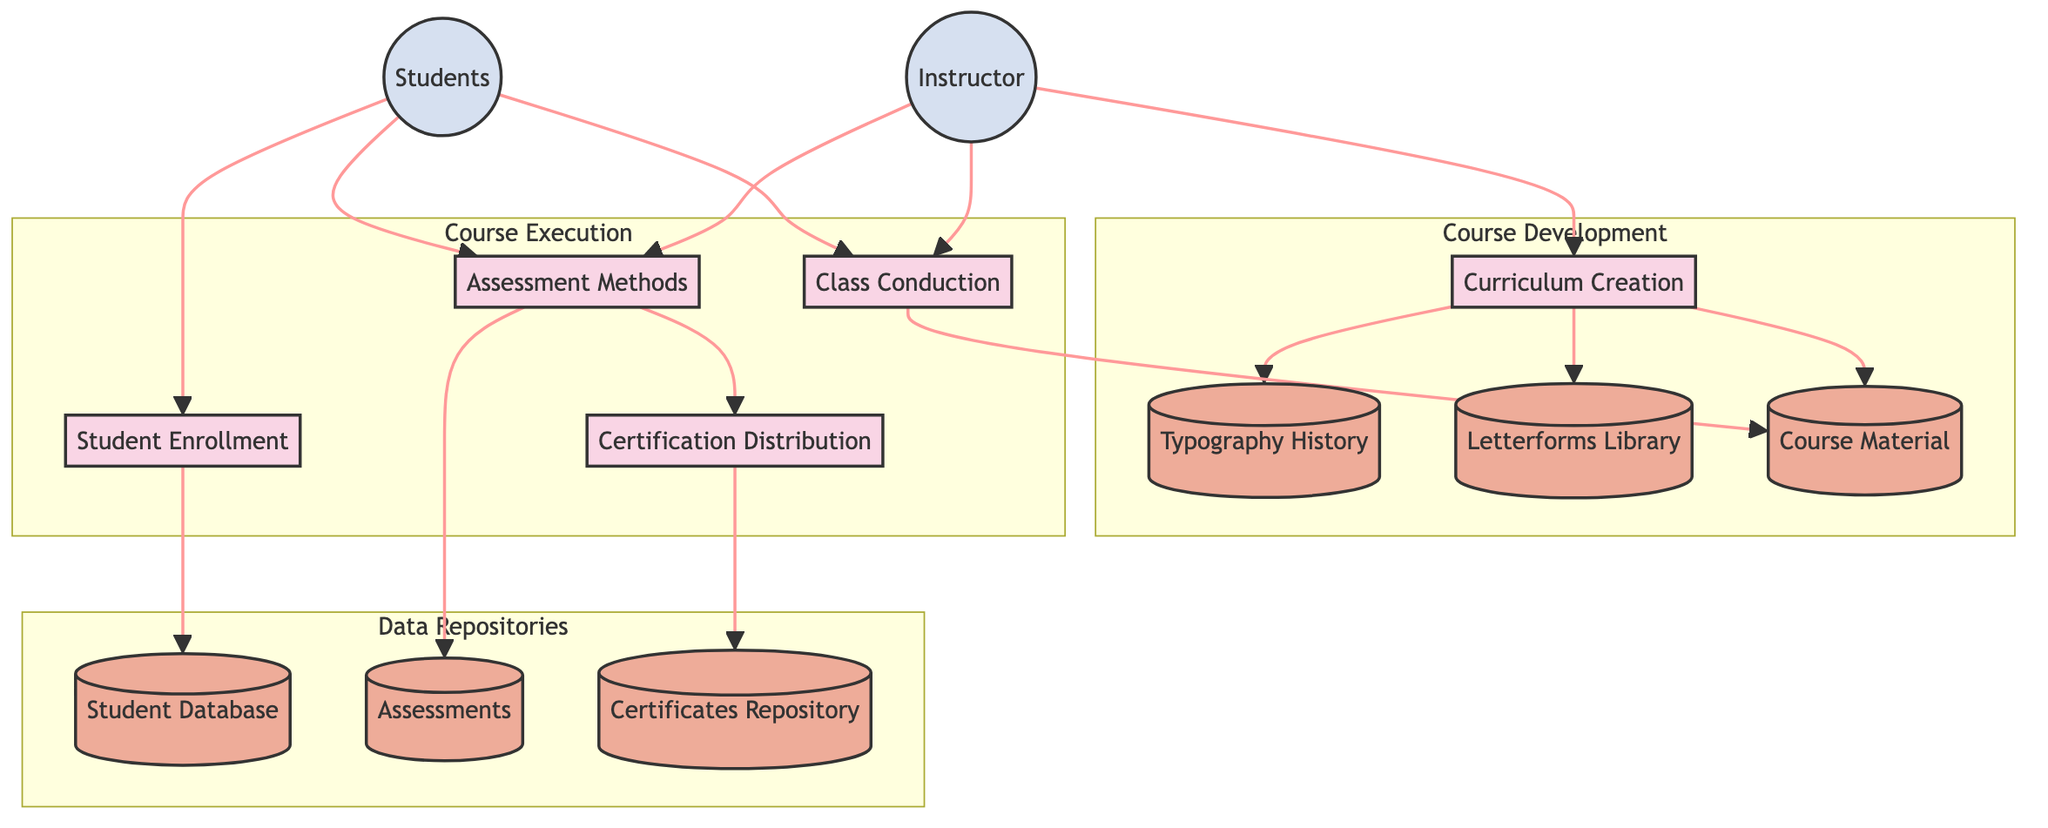What is the first process in the diagram? The first process that appears in the Data Flow Diagram is "Curriculum Creation." It is the starting point of the course development sequence.
Answer: Curriculum Creation How many data stores are present in the diagram? The diagram includes six data stores: Typography History, Letterforms Library, Student Database, Assessments, Certificates Repository, and Course Material.
Answer: Six Which external entity is involved in class conduction? The external entity involved in class conduction is the "Instructor," who is responsible for executing the classes.
Answer: Instructor What is the relationship between Assessment Methods and Certification Distribution? "Assessment Methods" leads directly into "Certification Distribution," indicating that assessments influence the issuance of certificates after course completion.
Answer: Direct relationship How many processes are in the course execution subgraph? There are four processes within the "Course Execution" subgraph: Student Enrollment, Class Conduction, Assessment Methods, and Certification Distribution.
Answer: Four Which data store contains student information? The "Student Database" holds all the information regarding students and their enrollment details for the typographic design course.
Answer: Student Database What does the Letterforms Library represent? The "Letterforms Library" serves as a data store that contains a database of various letterforms and their design principles, which are critical resources for the course.
Answer: Letterforms Library Which process is directly connected to the Student entity? The "Student Enrollment" process is directly connected to the "Students" entity, indicating that students are involved in the enrollment procedure.
Answer: Student Enrollment What is the output of the Assessment Methods process? The output of the "Assessment Methods" process primarily results in the storage of student evaluations in the "Assessments" data store.
Answer: Assessments 